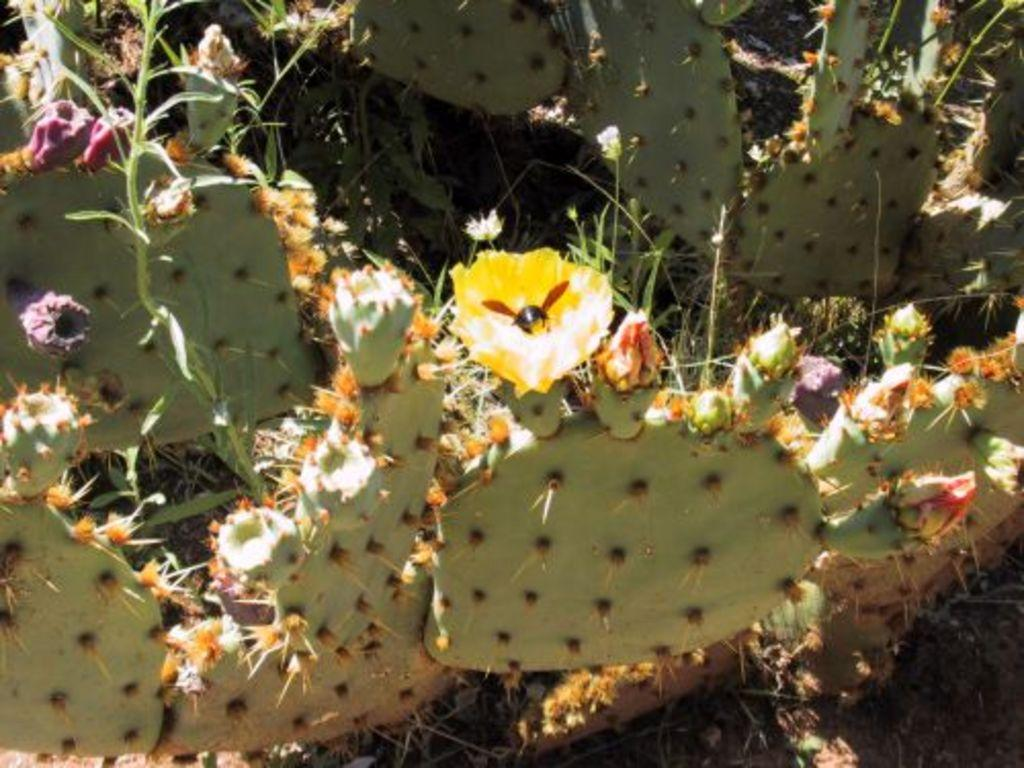What type of living organism can be seen in the image? There is a plant in the image. What is the color of the plant? The plant is green. What is present on the flower of the plant? There is an insect on the flower. What colors can be seen on the insect? The insect is in black and brown color. What is the color of the flower? The flower is in yellow color. What type of battle is taking place in the image? There is no battle present in the image; it features a plant with an insect on its flower. What is the plot of the story depicted in the image? There is no story depicted in the image; it is a simple representation of a plant with an insect on its flower. 